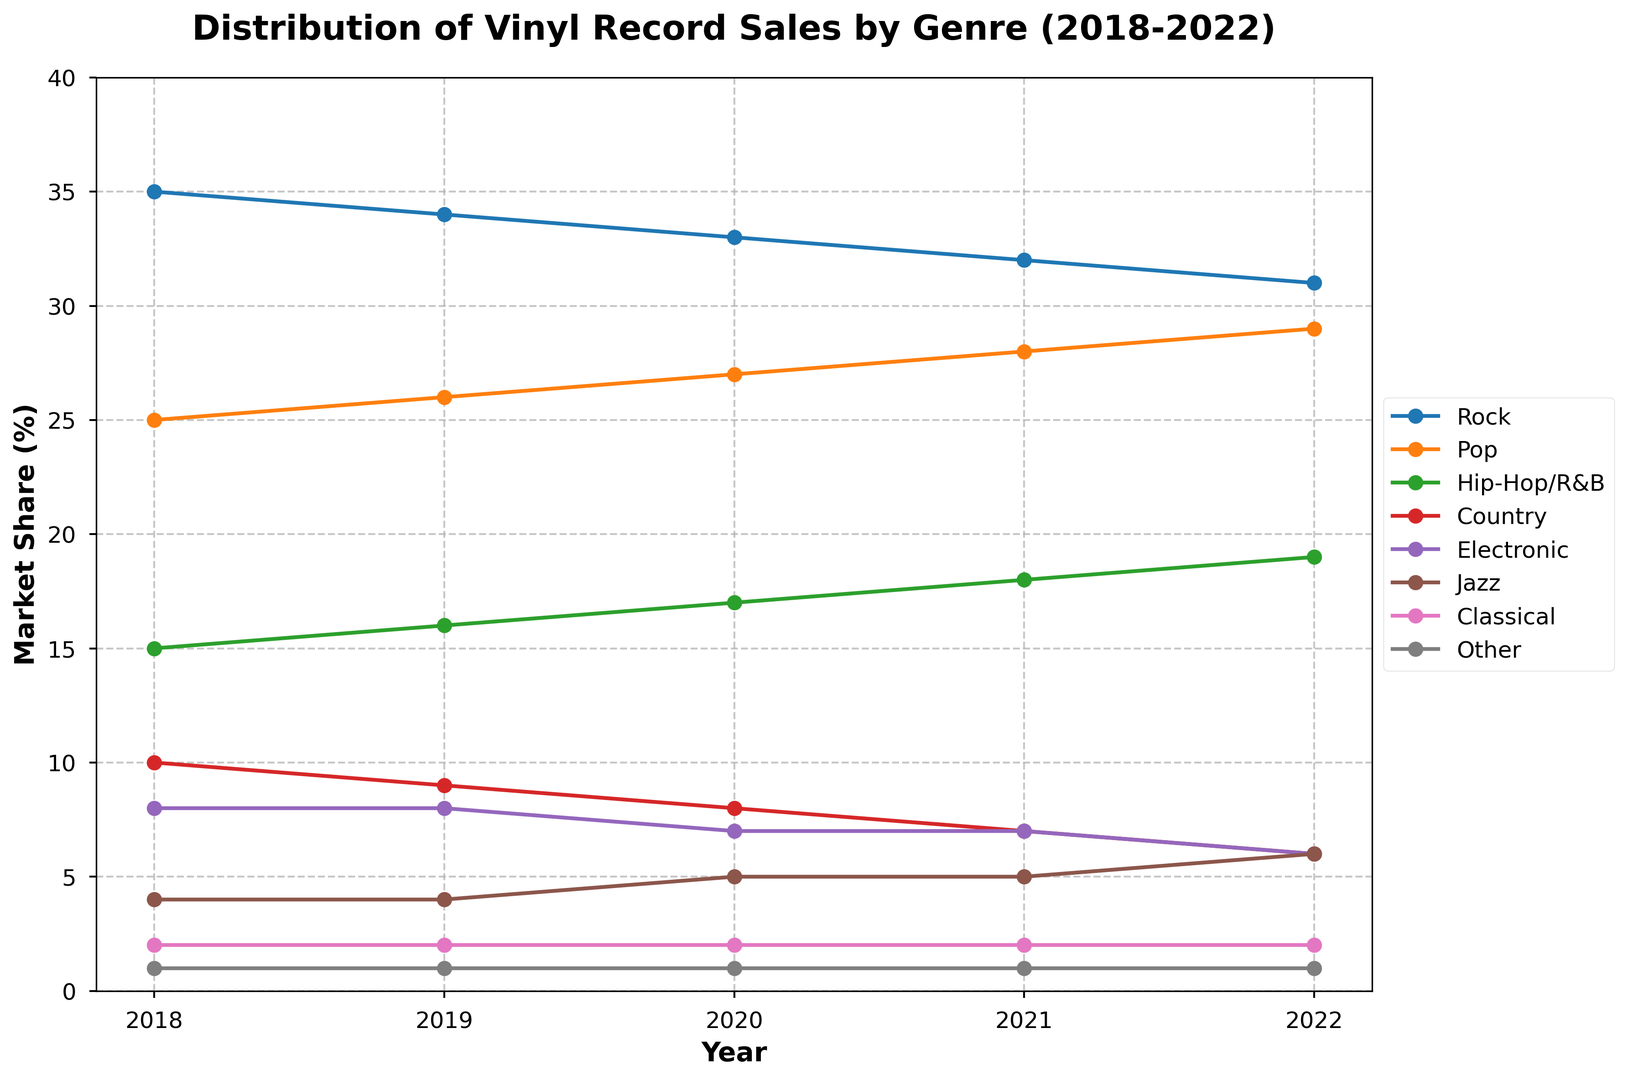How has the market share for Jazz changed from 2018 to 2022? The figure includes a highlighted annotation indicating that Jazz's market share increased from 4% in 2018 to 6% in 2022, alongside an arrow marking this trend visually.
Answer: Increased from 4% to 6% Which genre had the highest market share in 2022? By looking at the end point of the lines for each genre in 2022, the Rock genre had the highest market share, reaching 31%.
Answer: Rock What was the combined market share of Pop and Hip-Hop/R&B in 2020? In 2020, Pop had a market share of 27% and Hip-Hop/R&B had 17%. Adding these together yields 44%.
Answer: 44% Which genre displayed a continuous decline every year between 2018 and 2022? The figure shows that Rock, Country, and Electronic all displayed decreasing trends over the five years, but Country shows the most consistent yearly decline, dropping from 10% to 6%.
Answer: Country Compare the market share trends of Jazz and Classical genres from 2018 to 2022. Jazz increased from 4% to 6%, while Classical remained steady at 2% throughout the period. By comparing their slopes, Jazz shows an upward trend whereas Classical shows no change.
Answer: Jazz increased, Classical remained steady How much did Rock's market share decrease from 2018 to 2022? Rock started at 35% in 2018 and dropped to 31% in 2022. The difference is 35 - 31 = 4%.
Answer: 4% Which genre had no change in market share over the period and what was its value? The Classical genre remained at 2% market share throughout all five years, as indicated by the flat line in the figure.
Answer: Classical at 2% Based on the figure, what visual attribute highlights the change in Jazz’s market share? The figure uses a text annotation and a distinctive yellow box with an arrow pointing out the increase in Jazz's market share, visually highlighting this trend.
Answer: Yellow box annotation and arrow What is the trend for Electronic music from 2018 to 2022, and how does it compare to Pop? Electronic music decreased from 8% to 6%, showing a downward trend. In contrast, Pop increased from 25% to 29%, representing an upward trend.
Answer: Electronic decreased, Pop increased What is the average market share of Hip-Hop/R&B from 2018 to 2022? The average is calculated by summing the market shares for each year (15 + 16 + 17 + 18 + 19) and dividing by the number of years, 5. Thus, (15 + 16 + 17 + 18 + 19) / 5 = 17%.
Answer: 17% 